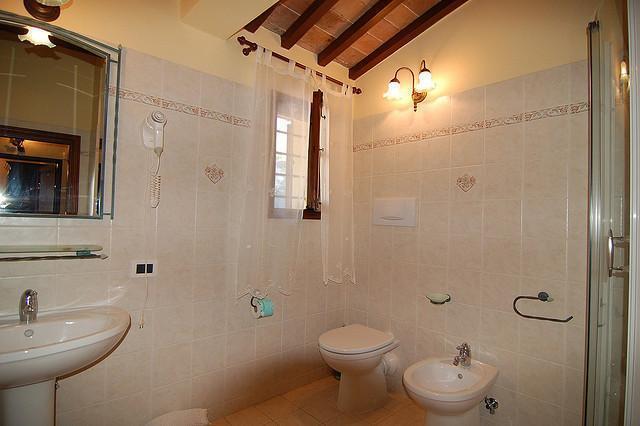How many places could an animal get water from here?
Pick the correct solution from the four options below to address the question.
Options: Three, five, eight, six. Three. 